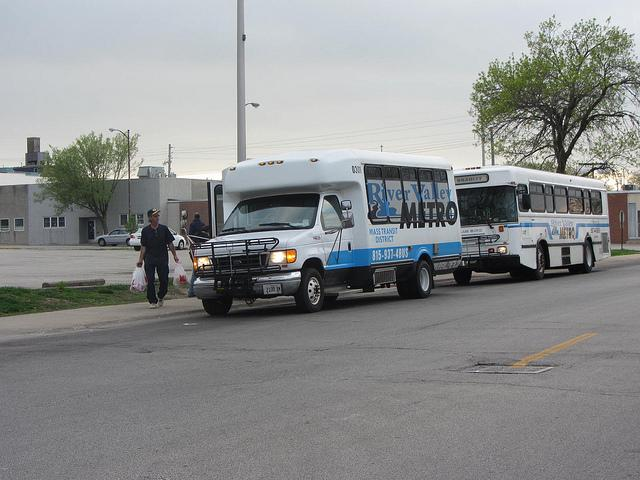What did the man on the sidewalk most likely just do? Please explain your reasoning. shop. He is holding two grocery bags so he probably just bought food. 